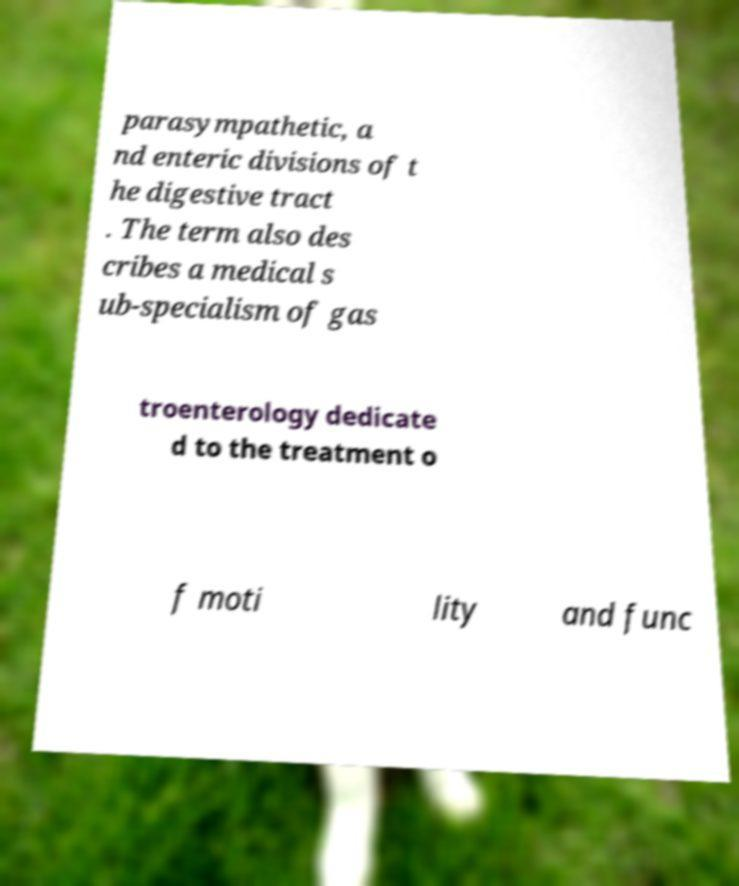Could you assist in decoding the text presented in this image and type it out clearly? parasympathetic, a nd enteric divisions of t he digestive tract . The term also des cribes a medical s ub-specialism of gas troenterology dedicate d to the treatment o f moti lity and func 